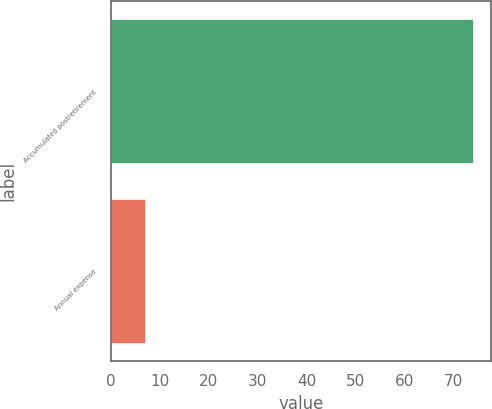<chart> <loc_0><loc_0><loc_500><loc_500><bar_chart><fcel>Accumulated postretirement<fcel>Annual expense<nl><fcel>74<fcel>7<nl></chart> 